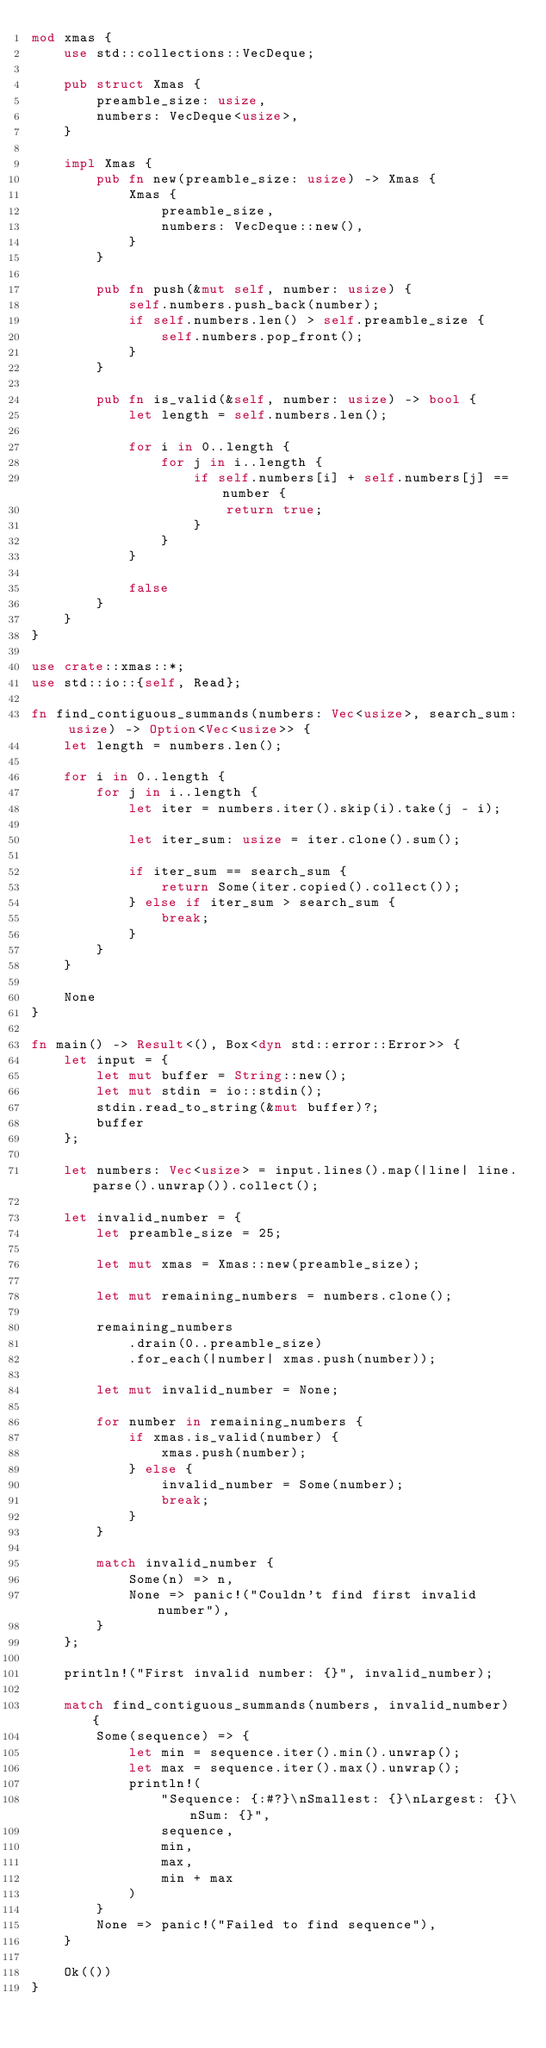Convert code to text. <code><loc_0><loc_0><loc_500><loc_500><_Rust_>mod xmas {
    use std::collections::VecDeque;

    pub struct Xmas {
        preamble_size: usize,
        numbers: VecDeque<usize>,
    }

    impl Xmas {
        pub fn new(preamble_size: usize) -> Xmas {
            Xmas {
                preamble_size,
                numbers: VecDeque::new(),
            }
        }

        pub fn push(&mut self, number: usize) {
            self.numbers.push_back(number);
            if self.numbers.len() > self.preamble_size {
                self.numbers.pop_front();
            }
        }

        pub fn is_valid(&self, number: usize) -> bool {
            let length = self.numbers.len();

            for i in 0..length {
                for j in i..length {
                    if self.numbers[i] + self.numbers[j] == number {
                        return true;
                    }
                }
            }

            false
        }
    }
}

use crate::xmas::*;
use std::io::{self, Read};

fn find_contiguous_summands(numbers: Vec<usize>, search_sum: usize) -> Option<Vec<usize>> {
    let length = numbers.len();

    for i in 0..length {
        for j in i..length {
            let iter = numbers.iter().skip(i).take(j - i);

            let iter_sum: usize = iter.clone().sum();

            if iter_sum == search_sum {
                return Some(iter.copied().collect());
            } else if iter_sum > search_sum {
                break;
            }
        }
    }

    None
}

fn main() -> Result<(), Box<dyn std::error::Error>> {
    let input = {
        let mut buffer = String::new();
        let mut stdin = io::stdin();
        stdin.read_to_string(&mut buffer)?;
        buffer
    };

    let numbers: Vec<usize> = input.lines().map(|line| line.parse().unwrap()).collect();

    let invalid_number = {
        let preamble_size = 25;

        let mut xmas = Xmas::new(preamble_size);

        let mut remaining_numbers = numbers.clone();

        remaining_numbers
            .drain(0..preamble_size)
            .for_each(|number| xmas.push(number));

        let mut invalid_number = None;

        for number in remaining_numbers {
            if xmas.is_valid(number) {
                xmas.push(number);
            } else {
                invalid_number = Some(number);
                break;
            }
        }

        match invalid_number {
            Some(n) => n,
            None => panic!("Couldn't find first invalid number"),
        }
    };

    println!("First invalid number: {}", invalid_number);

    match find_contiguous_summands(numbers, invalid_number) {
        Some(sequence) => {
            let min = sequence.iter().min().unwrap();
            let max = sequence.iter().max().unwrap();
            println!(
                "Sequence: {:#?}\nSmallest: {}\nLargest: {}\nSum: {}",
                sequence,
                min,
                max,
                min + max
            )
        }
        None => panic!("Failed to find sequence"),
    }

    Ok(())
}
</code> 